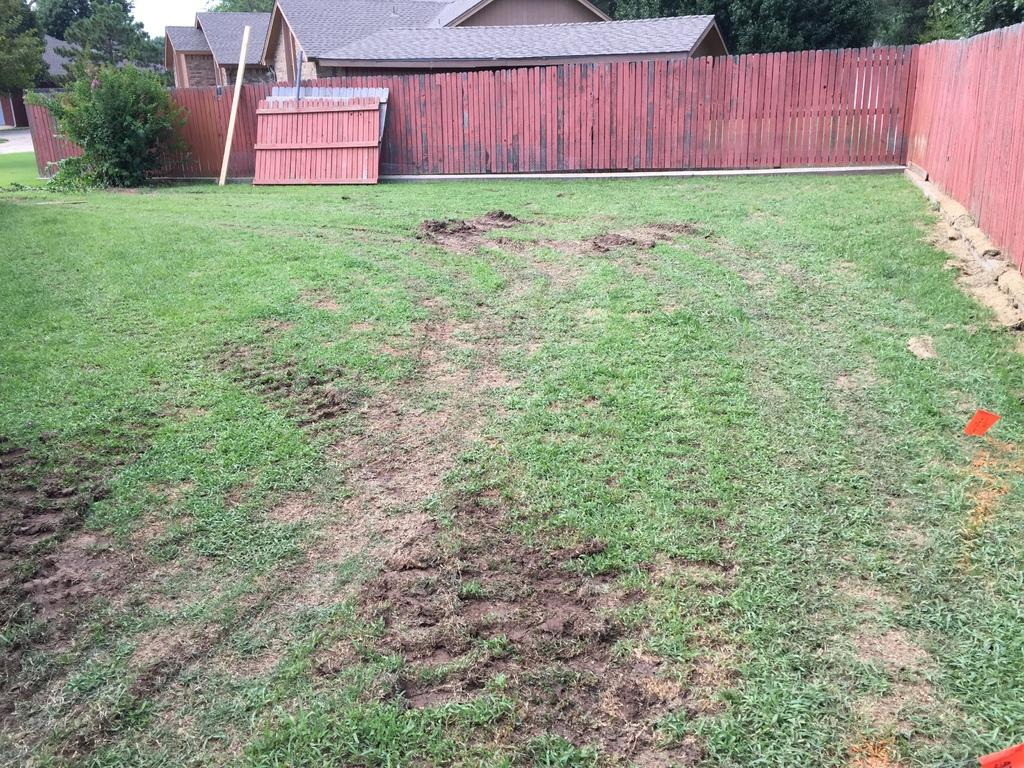What can be seen in the background of the image? There are buildings and trees in the background of the image. What type of barrier is present in the image? There is a boundary in the image. What is the terrain like in the foreground of the image? There is a grassland in the foreground of the image. What type of book is being used as a cork in the image? There is no book or cork present in the image. What process is being depicted in the image? The image does not depict a process; it shows a grassland, buildings, trees, and a boundary. 